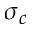<formula> <loc_0><loc_0><loc_500><loc_500>\sigma _ { c }</formula> 